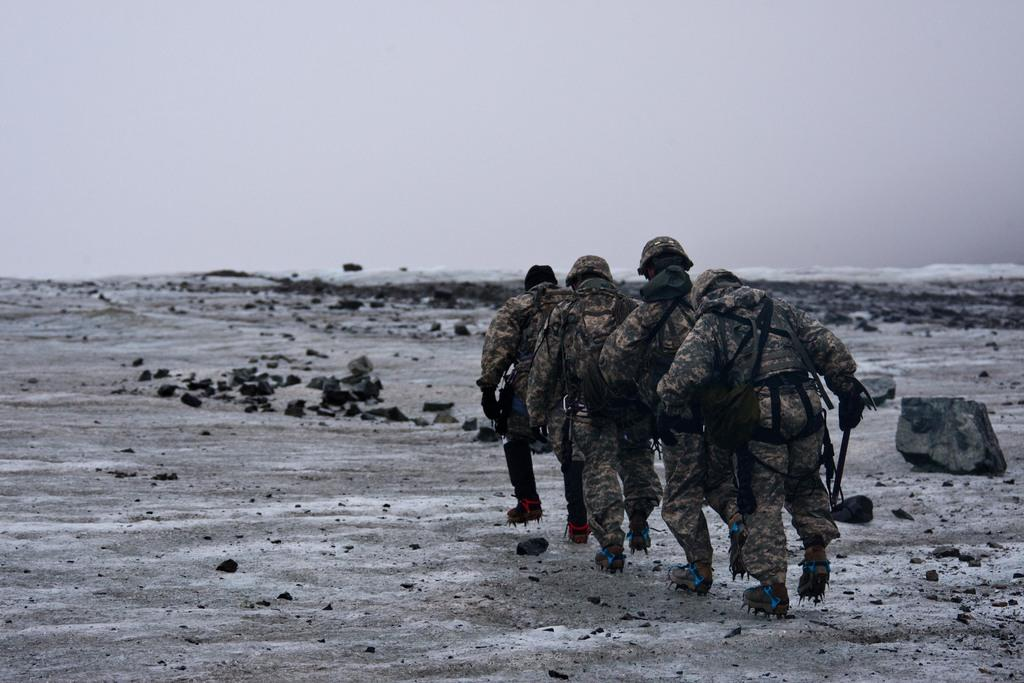Who or what is present in the image? There are people in the image. What are the people wearing on their heads? The people are wearing helmets. What feature can be seen on the people's shoes? The people have spikes on their shoes. What are the people carrying in the image? The people are carrying bags. How would you describe the sky in the image? The sky is cloudy in the image. What type of terrain is visible in the image? There are rocks on the ground in the image. What type of heart-shaped object can be seen in the image? There is no heart-shaped object present in the image. What is the quince doing in the image? There is no quince present in the image. 